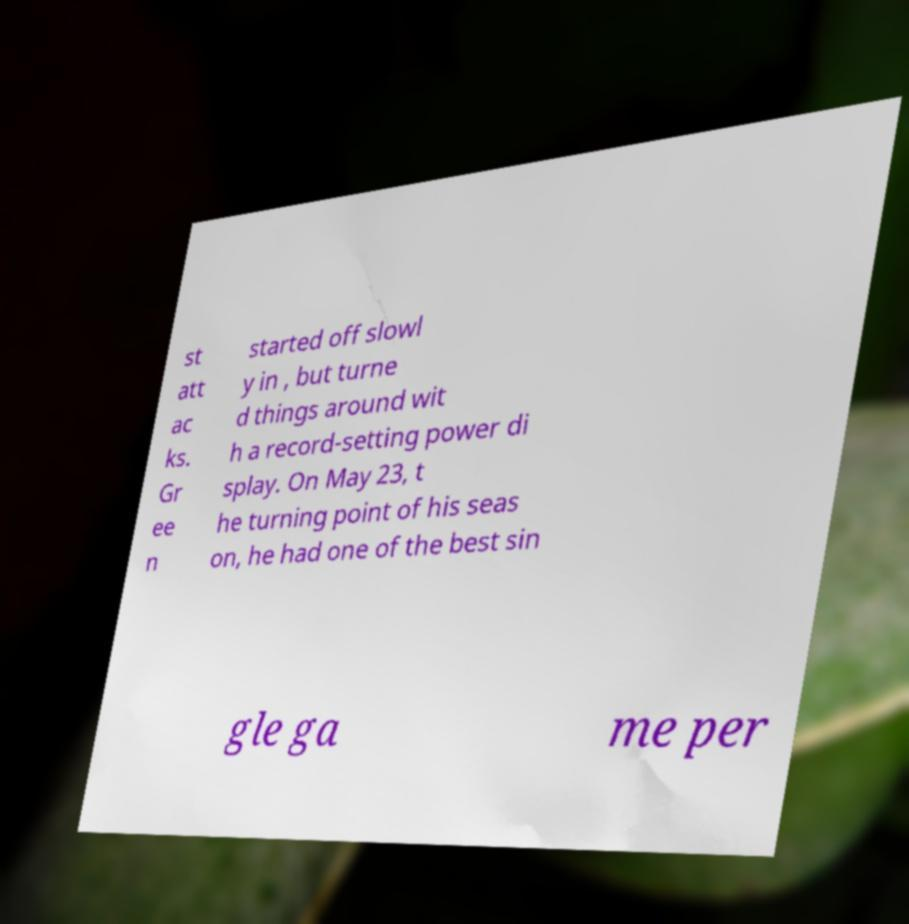I need the written content from this picture converted into text. Can you do that? st att ac ks. Gr ee n started off slowl y in , but turne d things around wit h a record-setting power di splay. On May 23, t he turning point of his seas on, he had one of the best sin gle ga me per 